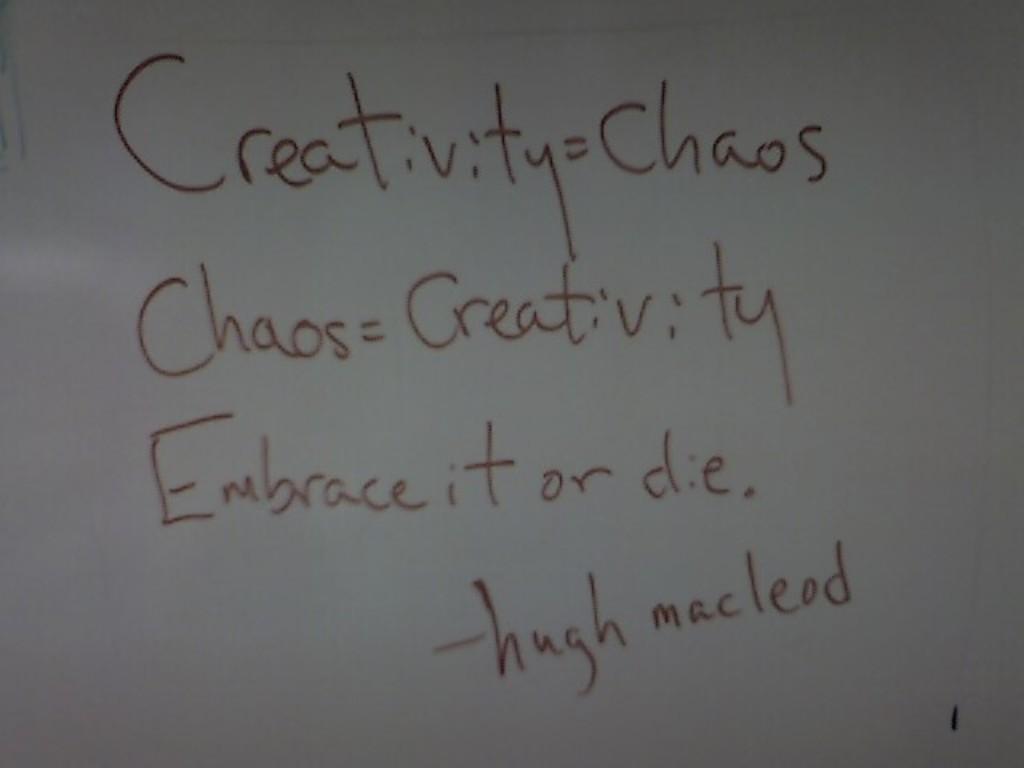Embrace what or die?
Provide a short and direct response. It. Who is this quote by?
Offer a very short reply. Hugh macleod. 